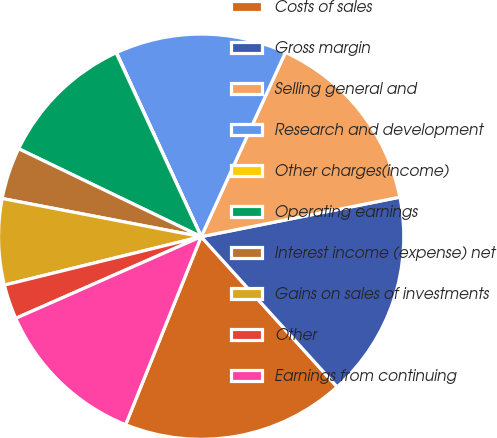<chart> <loc_0><loc_0><loc_500><loc_500><pie_chart><fcel>Costs of sales<fcel>Gross margin<fcel>Selling general and<fcel>Research and development<fcel>Other charges(income)<fcel>Operating earnings<fcel>Interest income (expense) net<fcel>Gains on sales of investments<fcel>Other<fcel>Earnings from continuing<nl><fcel>17.79%<fcel>16.42%<fcel>15.05%<fcel>13.69%<fcel>0.03%<fcel>10.96%<fcel>4.13%<fcel>6.86%<fcel>2.76%<fcel>12.32%<nl></chart> 